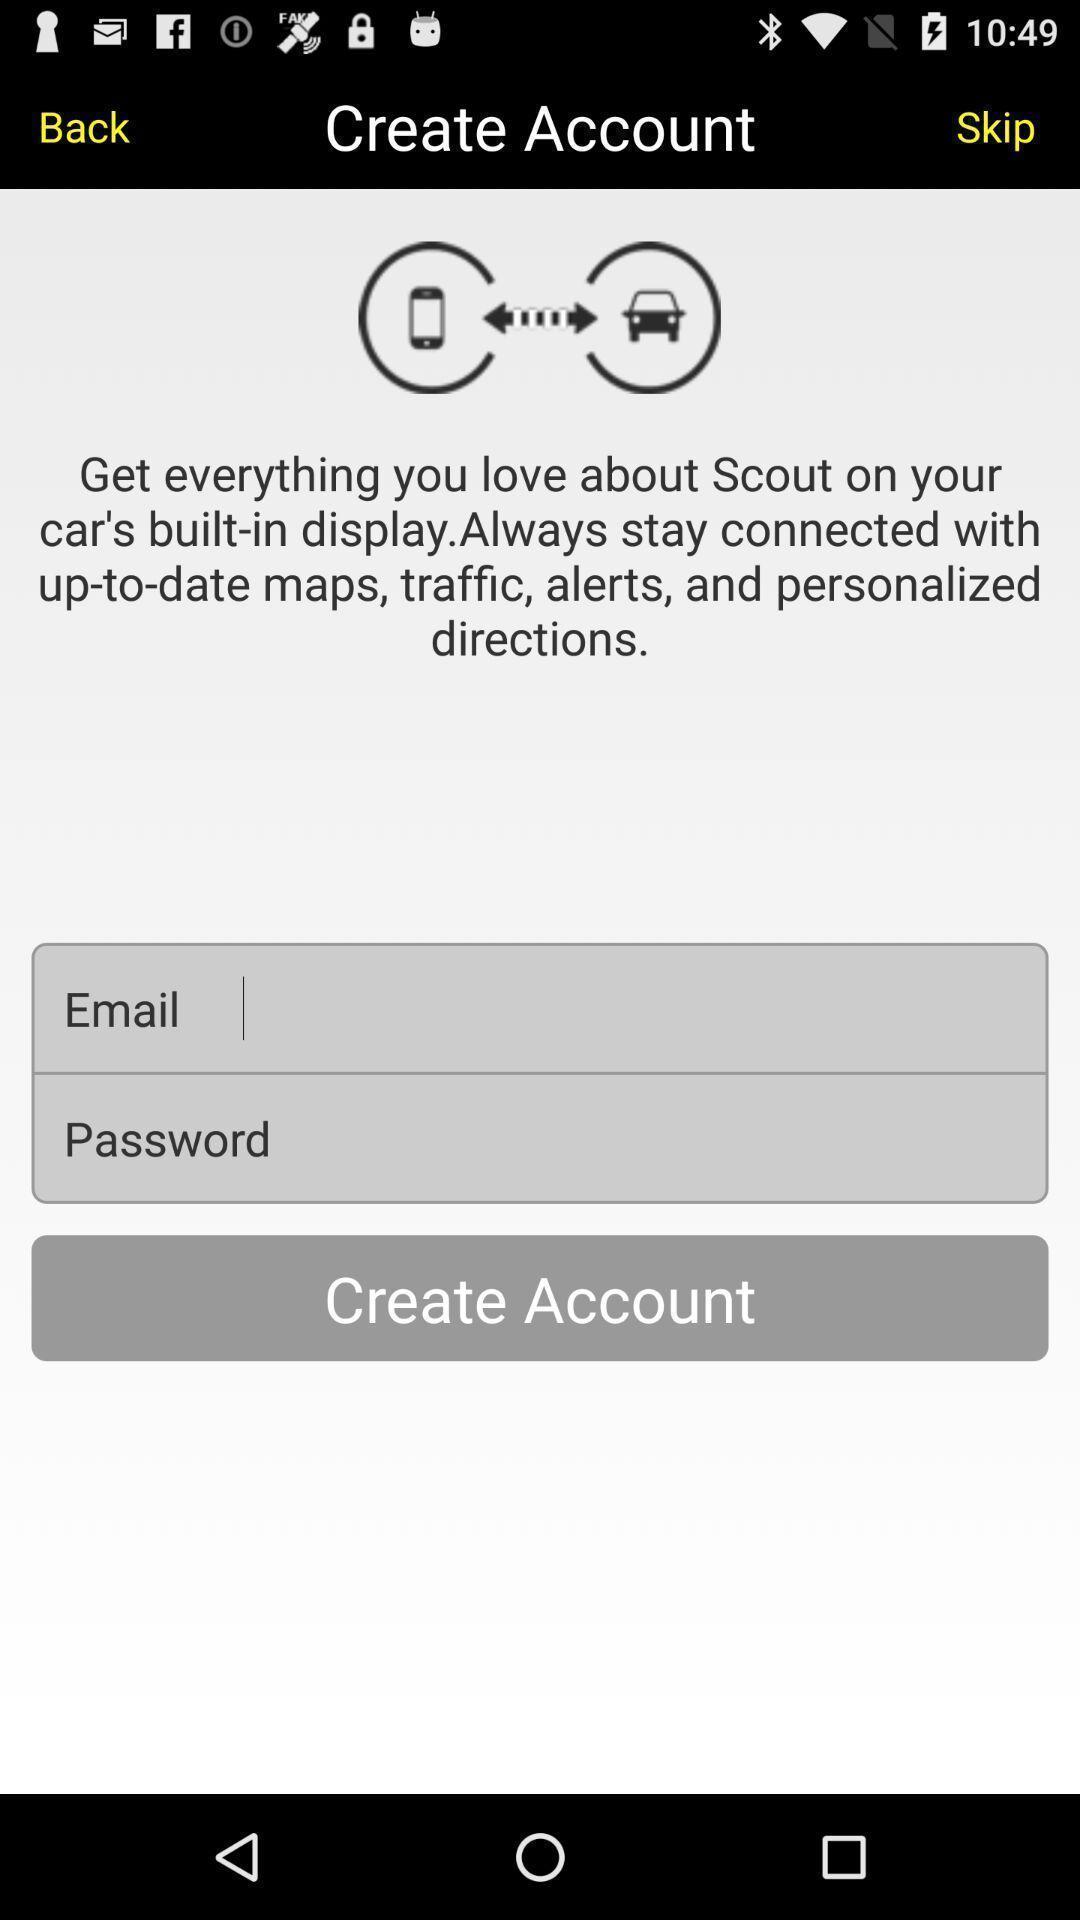Give me a summary of this screen capture. Screen showing create account page. 